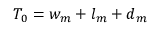Convert formula to latex. <formula><loc_0><loc_0><loc_500><loc_500>T _ { 0 } = w _ { m } + l _ { m } + d _ { m }</formula> 